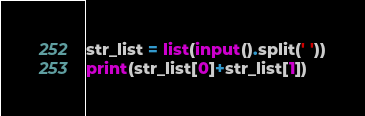<code> <loc_0><loc_0><loc_500><loc_500><_Python_>str_list = list(input().split(' '))
print(str_list[0]+str_list[1])
</code> 